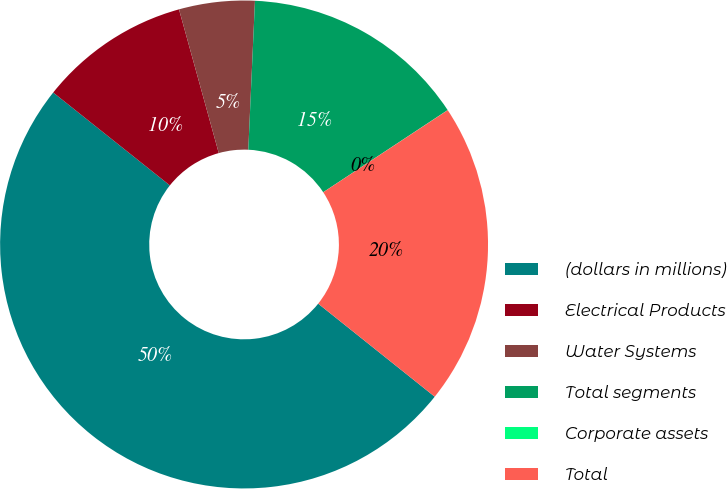Convert chart to OTSL. <chart><loc_0><loc_0><loc_500><loc_500><pie_chart><fcel>(dollars in millions)<fcel>Electrical Products<fcel>Water Systems<fcel>Total segments<fcel>Corporate assets<fcel>Total<nl><fcel>49.98%<fcel>10.0%<fcel>5.01%<fcel>15.0%<fcel>0.01%<fcel>20.0%<nl></chart> 